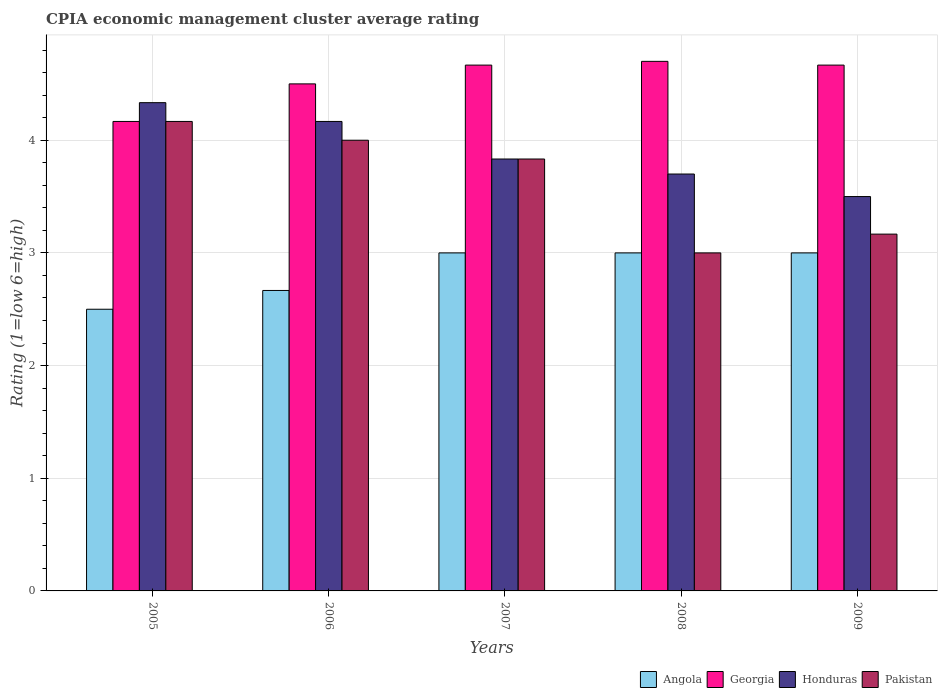How many different coloured bars are there?
Your answer should be compact. 4. How many groups of bars are there?
Provide a succinct answer. 5. Are the number of bars per tick equal to the number of legend labels?
Provide a succinct answer. Yes. How many bars are there on the 5th tick from the left?
Keep it short and to the point. 4. What is the label of the 1st group of bars from the left?
Your answer should be compact. 2005. In how many cases, is the number of bars for a given year not equal to the number of legend labels?
Offer a terse response. 0. Across all years, what is the maximum CPIA rating in Honduras?
Give a very brief answer. 4.33. In which year was the CPIA rating in Georgia maximum?
Provide a short and direct response. 2008. What is the total CPIA rating in Georgia in the graph?
Provide a short and direct response. 22.7. What is the difference between the CPIA rating in Pakistan in 2006 and that in 2007?
Ensure brevity in your answer.  0.17. What is the difference between the CPIA rating in Angola in 2005 and the CPIA rating in Honduras in 2006?
Provide a succinct answer. -1.67. What is the average CPIA rating in Honduras per year?
Provide a short and direct response. 3.91. In the year 2005, what is the difference between the CPIA rating in Georgia and CPIA rating in Honduras?
Keep it short and to the point. -0.17. In how many years, is the CPIA rating in Pakistan greater than 3.6?
Make the answer very short. 3. What is the ratio of the CPIA rating in Angola in 2005 to that in 2008?
Offer a very short reply. 0.83. Is the difference between the CPIA rating in Georgia in 2005 and 2006 greater than the difference between the CPIA rating in Honduras in 2005 and 2006?
Keep it short and to the point. No. What is the difference between the highest and the second highest CPIA rating in Honduras?
Keep it short and to the point. 0.17. What is the difference between the highest and the lowest CPIA rating in Georgia?
Provide a short and direct response. 0.53. In how many years, is the CPIA rating in Honduras greater than the average CPIA rating in Honduras taken over all years?
Ensure brevity in your answer.  2. Is the sum of the CPIA rating in Honduras in 2007 and 2008 greater than the maximum CPIA rating in Pakistan across all years?
Provide a short and direct response. Yes. Is it the case that in every year, the sum of the CPIA rating in Georgia and CPIA rating in Angola is greater than the sum of CPIA rating in Honduras and CPIA rating in Pakistan?
Provide a succinct answer. No. What does the 2nd bar from the left in 2007 represents?
Provide a short and direct response. Georgia. What does the 4th bar from the right in 2007 represents?
Give a very brief answer. Angola. Is it the case that in every year, the sum of the CPIA rating in Pakistan and CPIA rating in Angola is greater than the CPIA rating in Honduras?
Offer a very short reply. Yes. How many bars are there?
Provide a succinct answer. 20. How many years are there in the graph?
Give a very brief answer. 5. Does the graph contain grids?
Ensure brevity in your answer.  Yes. Where does the legend appear in the graph?
Your response must be concise. Bottom right. How many legend labels are there?
Keep it short and to the point. 4. How are the legend labels stacked?
Ensure brevity in your answer.  Horizontal. What is the title of the graph?
Ensure brevity in your answer.  CPIA economic management cluster average rating. Does "Jamaica" appear as one of the legend labels in the graph?
Provide a succinct answer. No. What is the label or title of the Y-axis?
Your response must be concise. Rating (1=low 6=high). What is the Rating (1=low 6=high) in Angola in 2005?
Your answer should be very brief. 2.5. What is the Rating (1=low 6=high) of Georgia in 2005?
Provide a succinct answer. 4.17. What is the Rating (1=low 6=high) in Honduras in 2005?
Offer a terse response. 4.33. What is the Rating (1=low 6=high) of Pakistan in 2005?
Offer a terse response. 4.17. What is the Rating (1=low 6=high) in Angola in 2006?
Your answer should be compact. 2.67. What is the Rating (1=low 6=high) in Honduras in 2006?
Ensure brevity in your answer.  4.17. What is the Rating (1=low 6=high) of Pakistan in 2006?
Offer a very short reply. 4. What is the Rating (1=low 6=high) of Angola in 2007?
Provide a succinct answer. 3. What is the Rating (1=low 6=high) in Georgia in 2007?
Give a very brief answer. 4.67. What is the Rating (1=low 6=high) in Honduras in 2007?
Ensure brevity in your answer.  3.83. What is the Rating (1=low 6=high) of Pakistan in 2007?
Your answer should be compact. 3.83. What is the Rating (1=low 6=high) in Angola in 2008?
Your answer should be compact. 3. What is the Rating (1=low 6=high) in Georgia in 2008?
Offer a terse response. 4.7. What is the Rating (1=low 6=high) of Angola in 2009?
Provide a succinct answer. 3. What is the Rating (1=low 6=high) of Georgia in 2009?
Your answer should be compact. 4.67. What is the Rating (1=low 6=high) of Pakistan in 2009?
Your answer should be very brief. 3.17. Across all years, what is the maximum Rating (1=low 6=high) in Georgia?
Offer a terse response. 4.7. Across all years, what is the maximum Rating (1=low 6=high) in Honduras?
Give a very brief answer. 4.33. Across all years, what is the maximum Rating (1=low 6=high) in Pakistan?
Your answer should be compact. 4.17. Across all years, what is the minimum Rating (1=low 6=high) in Georgia?
Provide a succinct answer. 4.17. Across all years, what is the minimum Rating (1=low 6=high) of Pakistan?
Give a very brief answer. 3. What is the total Rating (1=low 6=high) in Angola in the graph?
Ensure brevity in your answer.  14.17. What is the total Rating (1=low 6=high) of Georgia in the graph?
Keep it short and to the point. 22.7. What is the total Rating (1=low 6=high) in Honduras in the graph?
Your response must be concise. 19.53. What is the total Rating (1=low 6=high) of Pakistan in the graph?
Your response must be concise. 18.17. What is the difference between the Rating (1=low 6=high) of Honduras in 2005 and that in 2006?
Offer a terse response. 0.17. What is the difference between the Rating (1=low 6=high) of Pakistan in 2005 and that in 2006?
Ensure brevity in your answer.  0.17. What is the difference between the Rating (1=low 6=high) in Honduras in 2005 and that in 2007?
Provide a short and direct response. 0.5. What is the difference between the Rating (1=low 6=high) in Pakistan in 2005 and that in 2007?
Provide a short and direct response. 0.33. What is the difference between the Rating (1=low 6=high) of Georgia in 2005 and that in 2008?
Your answer should be very brief. -0.53. What is the difference between the Rating (1=low 6=high) of Honduras in 2005 and that in 2008?
Your response must be concise. 0.63. What is the difference between the Rating (1=low 6=high) in Pakistan in 2005 and that in 2009?
Your answer should be compact. 1. What is the difference between the Rating (1=low 6=high) in Honduras in 2006 and that in 2008?
Your answer should be very brief. 0.47. What is the difference between the Rating (1=low 6=high) of Pakistan in 2006 and that in 2008?
Your response must be concise. 1. What is the difference between the Rating (1=low 6=high) in Angola in 2006 and that in 2009?
Provide a short and direct response. -0.33. What is the difference between the Rating (1=low 6=high) of Angola in 2007 and that in 2008?
Give a very brief answer. 0. What is the difference between the Rating (1=low 6=high) in Georgia in 2007 and that in 2008?
Provide a short and direct response. -0.03. What is the difference between the Rating (1=low 6=high) in Honduras in 2007 and that in 2008?
Your answer should be very brief. 0.13. What is the difference between the Rating (1=low 6=high) in Pakistan in 2007 and that in 2008?
Offer a terse response. 0.83. What is the difference between the Rating (1=low 6=high) of Honduras in 2007 and that in 2009?
Provide a succinct answer. 0.33. What is the difference between the Rating (1=low 6=high) of Angola in 2008 and that in 2009?
Provide a succinct answer. 0. What is the difference between the Rating (1=low 6=high) in Georgia in 2008 and that in 2009?
Ensure brevity in your answer.  0.03. What is the difference between the Rating (1=low 6=high) in Honduras in 2008 and that in 2009?
Make the answer very short. 0.2. What is the difference between the Rating (1=low 6=high) in Pakistan in 2008 and that in 2009?
Give a very brief answer. -0.17. What is the difference between the Rating (1=low 6=high) of Angola in 2005 and the Rating (1=low 6=high) of Honduras in 2006?
Provide a short and direct response. -1.67. What is the difference between the Rating (1=low 6=high) in Georgia in 2005 and the Rating (1=low 6=high) in Honduras in 2006?
Ensure brevity in your answer.  0. What is the difference between the Rating (1=low 6=high) in Honduras in 2005 and the Rating (1=low 6=high) in Pakistan in 2006?
Your response must be concise. 0.33. What is the difference between the Rating (1=low 6=high) of Angola in 2005 and the Rating (1=low 6=high) of Georgia in 2007?
Your answer should be very brief. -2.17. What is the difference between the Rating (1=low 6=high) in Angola in 2005 and the Rating (1=low 6=high) in Honduras in 2007?
Provide a succinct answer. -1.33. What is the difference between the Rating (1=low 6=high) in Angola in 2005 and the Rating (1=low 6=high) in Pakistan in 2007?
Keep it short and to the point. -1.33. What is the difference between the Rating (1=low 6=high) in Honduras in 2005 and the Rating (1=low 6=high) in Pakistan in 2007?
Offer a very short reply. 0.5. What is the difference between the Rating (1=low 6=high) of Georgia in 2005 and the Rating (1=low 6=high) of Honduras in 2008?
Offer a terse response. 0.47. What is the difference between the Rating (1=low 6=high) of Georgia in 2005 and the Rating (1=low 6=high) of Pakistan in 2008?
Offer a very short reply. 1.17. What is the difference between the Rating (1=low 6=high) of Angola in 2005 and the Rating (1=low 6=high) of Georgia in 2009?
Offer a terse response. -2.17. What is the difference between the Rating (1=low 6=high) in Angola in 2005 and the Rating (1=low 6=high) in Pakistan in 2009?
Ensure brevity in your answer.  -0.67. What is the difference between the Rating (1=low 6=high) in Honduras in 2005 and the Rating (1=low 6=high) in Pakistan in 2009?
Make the answer very short. 1.17. What is the difference between the Rating (1=low 6=high) in Angola in 2006 and the Rating (1=low 6=high) in Honduras in 2007?
Your answer should be very brief. -1.17. What is the difference between the Rating (1=low 6=high) in Angola in 2006 and the Rating (1=low 6=high) in Pakistan in 2007?
Your answer should be compact. -1.17. What is the difference between the Rating (1=low 6=high) in Georgia in 2006 and the Rating (1=low 6=high) in Honduras in 2007?
Give a very brief answer. 0.67. What is the difference between the Rating (1=low 6=high) of Angola in 2006 and the Rating (1=low 6=high) of Georgia in 2008?
Offer a very short reply. -2.03. What is the difference between the Rating (1=low 6=high) in Angola in 2006 and the Rating (1=low 6=high) in Honduras in 2008?
Provide a succinct answer. -1.03. What is the difference between the Rating (1=low 6=high) of Angola in 2006 and the Rating (1=low 6=high) of Pakistan in 2008?
Your response must be concise. -0.33. What is the difference between the Rating (1=low 6=high) in Honduras in 2006 and the Rating (1=low 6=high) in Pakistan in 2008?
Ensure brevity in your answer.  1.17. What is the difference between the Rating (1=low 6=high) of Angola in 2006 and the Rating (1=low 6=high) of Georgia in 2009?
Offer a very short reply. -2. What is the difference between the Rating (1=low 6=high) in Angola in 2006 and the Rating (1=low 6=high) in Pakistan in 2009?
Your answer should be very brief. -0.5. What is the difference between the Rating (1=low 6=high) in Georgia in 2006 and the Rating (1=low 6=high) in Honduras in 2009?
Make the answer very short. 1. What is the difference between the Rating (1=low 6=high) in Georgia in 2006 and the Rating (1=low 6=high) in Pakistan in 2009?
Your answer should be compact. 1.33. What is the difference between the Rating (1=low 6=high) of Angola in 2007 and the Rating (1=low 6=high) of Honduras in 2008?
Your answer should be very brief. -0.7. What is the difference between the Rating (1=low 6=high) in Georgia in 2007 and the Rating (1=low 6=high) in Honduras in 2008?
Offer a terse response. 0.97. What is the difference between the Rating (1=low 6=high) in Honduras in 2007 and the Rating (1=low 6=high) in Pakistan in 2008?
Provide a succinct answer. 0.83. What is the difference between the Rating (1=low 6=high) of Angola in 2007 and the Rating (1=low 6=high) of Georgia in 2009?
Offer a very short reply. -1.67. What is the difference between the Rating (1=low 6=high) of Angola in 2007 and the Rating (1=low 6=high) of Honduras in 2009?
Provide a short and direct response. -0.5. What is the difference between the Rating (1=low 6=high) of Honduras in 2007 and the Rating (1=low 6=high) of Pakistan in 2009?
Offer a terse response. 0.67. What is the difference between the Rating (1=low 6=high) in Angola in 2008 and the Rating (1=low 6=high) in Georgia in 2009?
Make the answer very short. -1.67. What is the difference between the Rating (1=low 6=high) of Georgia in 2008 and the Rating (1=low 6=high) of Pakistan in 2009?
Keep it short and to the point. 1.53. What is the difference between the Rating (1=low 6=high) of Honduras in 2008 and the Rating (1=low 6=high) of Pakistan in 2009?
Ensure brevity in your answer.  0.53. What is the average Rating (1=low 6=high) in Angola per year?
Your answer should be very brief. 2.83. What is the average Rating (1=low 6=high) in Georgia per year?
Your answer should be very brief. 4.54. What is the average Rating (1=low 6=high) in Honduras per year?
Provide a short and direct response. 3.91. What is the average Rating (1=low 6=high) of Pakistan per year?
Provide a succinct answer. 3.63. In the year 2005, what is the difference between the Rating (1=low 6=high) in Angola and Rating (1=low 6=high) in Georgia?
Your response must be concise. -1.67. In the year 2005, what is the difference between the Rating (1=low 6=high) of Angola and Rating (1=low 6=high) of Honduras?
Your answer should be very brief. -1.83. In the year 2005, what is the difference between the Rating (1=low 6=high) of Angola and Rating (1=low 6=high) of Pakistan?
Provide a short and direct response. -1.67. In the year 2005, what is the difference between the Rating (1=low 6=high) of Georgia and Rating (1=low 6=high) of Honduras?
Provide a succinct answer. -0.17. In the year 2005, what is the difference between the Rating (1=low 6=high) in Honduras and Rating (1=low 6=high) in Pakistan?
Your answer should be very brief. 0.17. In the year 2006, what is the difference between the Rating (1=low 6=high) in Angola and Rating (1=low 6=high) in Georgia?
Ensure brevity in your answer.  -1.83. In the year 2006, what is the difference between the Rating (1=low 6=high) in Angola and Rating (1=low 6=high) in Honduras?
Offer a terse response. -1.5. In the year 2006, what is the difference between the Rating (1=low 6=high) in Angola and Rating (1=low 6=high) in Pakistan?
Offer a terse response. -1.33. In the year 2006, what is the difference between the Rating (1=low 6=high) of Honduras and Rating (1=low 6=high) of Pakistan?
Your response must be concise. 0.17. In the year 2007, what is the difference between the Rating (1=low 6=high) of Angola and Rating (1=low 6=high) of Georgia?
Ensure brevity in your answer.  -1.67. In the year 2007, what is the difference between the Rating (1=low 6=high) in Angola and Rating (1=low 6=high) in Honduras?
Give a very brief answer. -0.83. In the year 2007, what is the difference between the Rating (1=low 6=high) in Georgia and Rating (1=low 6=high) in Honduras?
Provide a short and direct response. 0.83. In the year 2007, what is the difference between the Rating (1=low 6=high) of Georgia and Rating (1=low 6=high) of Pakistan?
Offer a terse response. 0.83. In the year 2008, what is the difference between the Rating (1=low 6=high) in Angola and Rating (1=low 6=high) in Georgia?
Keep it short and to the point. -1.7. In the year 2008, what is the difference between the Rating (1=low 6=high) in Angola and Rating (1=low 6=high) in Honduras?
Keep it short and to the point. -0.7. In the year 2008, what is the difference between the Rating (1=low 6=high) of Georgia and Rating (1=low 6=high) of Pakistan?
Offer a very short reply. 1.7. In the year 2009, what is the difference between the Rating (1=low 6=high) of Angola and Rating (1=low 6=high) of Georgia?
Offer a terse response. -1.67. In the year 2009, what is the difference between the Rating (1=low 6=high) of Georgia and Rating (1=low 6=high) of Pakistan?
Make the answer very short. 1.5. What is the ratio of the Rating (1=low 6=high) in Angola in 2005 to that in 2006?
Offer a very short reply. 0.94. What is the ratio of the Rating (1=low 6=high) in Georgia in 2005 to that in 2006?
Your response must be concise. 0.93. What is the ratio of the Rating (1=low 6=high) in Pakistan in 2005 to that in 2006?
Make the answer very short. 1.04. What is the ratio of the Rating (1=low 6=high) in Angola in 2005 to that in 2007?
Offer a very short reply. 0.83. What is the ratio of the Rating (1=low 6=high) in Georgia in 2005 to that in 2007?
Your answer should be very brief. 0.89. What is the ratio of the Rating (1=low 6=high) of Honduras in 2005 to that in 2007?
Provide a short and direct response. 1.13. What is the ratio of the Rating (1=low 6=high) in Pakistan in 2005 to that in 2007?
Offer a very short reply. 1.09. What is the ratio of the Rating (1=low 6=high) in Georgia in 2005 to that in 2008?
Keep it short and to the point. 0.89. What is the ratio of the Rating (1=low 6=high) in Honduras in 2005 to that in 2008?
Your answer should be very brief. 1.17. What is the ratio of the Rating (1=low 6=high) of Pakistan in 2005 to that in 2008?
Offer a very short reply. 1.39. What is the ratio of the Rating (1=low 6=high) in Angola in 2005 to that in 2009?
Give a very brief answer. 0.83. What is the ratio of the Rating (1=low 6=high) of Georgia in 2005 to that in 2009?
Your answer should be compact. 0.89. What is the ratio of the Rating (1=low 6=high) in Honduras in 2005 to that in 2009?
Provide a succinct answer. 1.24. What is the ratio of the Rating (1=low 6=high) of Pakistan in 2005 to that in 2009?
Your answer should be very brief. 1.32. What is the ratio of the Rating (1=low 6=high) in Angola in 2006 to that in 2007?
Offer a terse response. 0.89. What is the ratio of the Rating (1=low 6=high) of Georgia in 2006 to that in 2007?
Your response must be concise. 0.96. What is the ratio of the Rating (1=low 6=high) of Honduras in 2006 to that in 2007?
Give a very brief answer. 1.09. What is the ratio of the Rating (1=low 6=high) of Pakistan in 2006 to that in 2007?
Your answer should be very brief. 1.04. What is the ratio of the Rating (1=low 6=high) in Georgia in 2006 to that in 2008?
Keep it short and to the point. 0.96. What is the ratio of the Rating (1=low 6=high) of Honduras in 2006 to that in 2008?
Provide a succinct answer. 1.13. What is the ratio of the Rating (1=low 6=high) of Angola in 2006 to that in 2009?
Your answer should be very brief. 0.89. What is the ratio of the Rating (1=low 6=high) of Honduras in 2006 to that in 2009?
Make the answer very short. 1.19. What is the ratio of the Rating (1=low 6=high) of Pakistan in 2006 to that in 2009?
Keep it short and to the point. 1.26. What is the ratio of the Rating (1=low 6=high) in Angola in 2007 to that in 2008?
Ensure brevity in your answer.  1. What is the ratio of the Rating (1=low 6=high) in Honduras in 2007 to that in 2008?
Keep it short and to the point. 1.04. What is the ratio of the Rating (1=low 6=high) of Pakistan in 2007 to that in 2008?
Give a very brief answer. 1.28. What is the ratio of the Rating (1=low 6=high) of Georgia in 2007 to that in 2009?
Your answer should be very brief. 1. What is the ratio of the Rating (1=low 6=high) in Honduras in 2007 to that in 2009?
Provide a short and direct response. 1.1. What is the ratio of the Rating (1=low 6=high) of Pakistan in 2007 to that in 2009?
Make the answer very short. 1.21. What is the ratio of the Rating (1=low 6=high) of Georgia in 2008 to that in 2009?
Your response must be concise. 1.01. What is the ratio of the Rating (1=low 6=high) in Honduras in 2008 to that in 2009?
Offer a very short reply. 1.06. What is the ratio of the Rating (1=low 6=high) in Pakistan in 2008 to that in 2009?
Ensure brevity in your answer.  0.95. What is the difference between the highest and the second highest Rating (1=low 6=high) of Pakistan?
Offer a very short reply. 0.17. What is the difference between the highest and the lowest Rating (1=low 6=high) in Angola?
Your response must be concise. 0.5. What is the difference between the highest and the lowest Rating (1=low 6=high) of Georgia?
Ensure brevity in your answer.  0.53. 